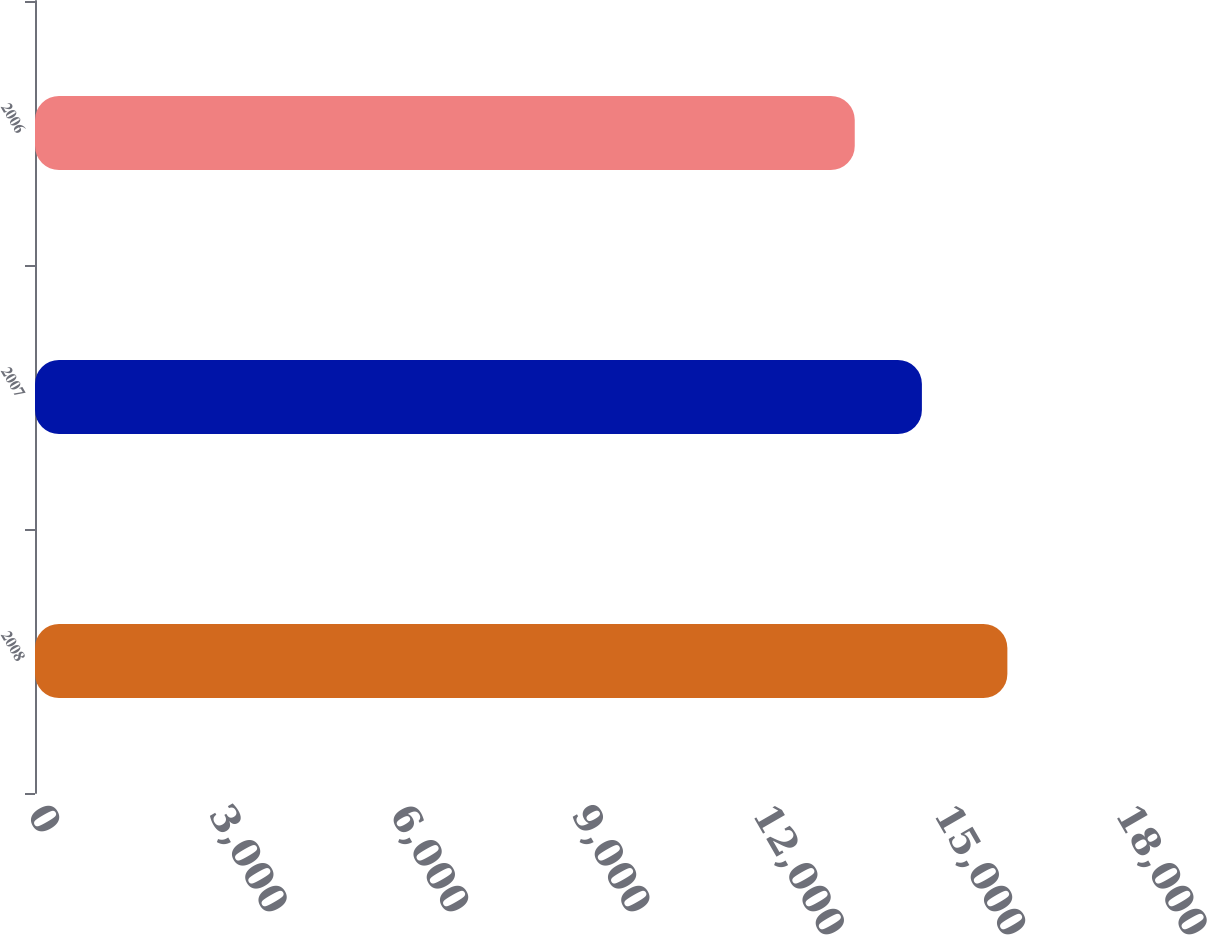Convert chart to OTSL. <chart><loc_0><loc_0><loc_500><loc_500><bar_chart><fcel>2008<fcel>2007<fcel>2006<nl><fcel>16087<fcel>14673<fcel>13562<nl></chart> 